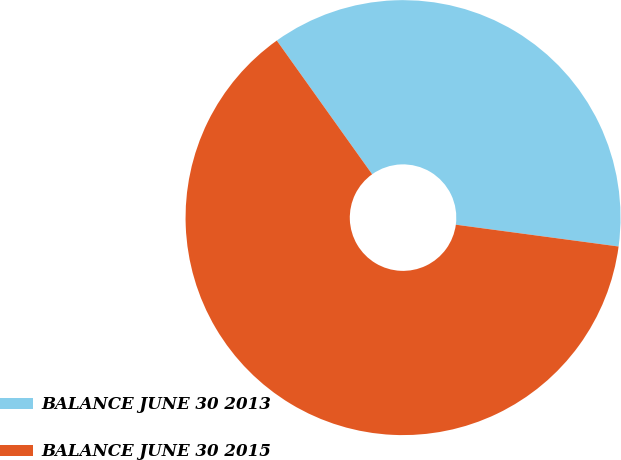<chart> <loc_0><loc_0><loc_500><loc_500><pie_chart><fcel>BALANCE JUNE 30 2013<fcel>BALANCE JUNE 30 2015<nl><fcel>36.98%<fcel>63.02%<nl></chart> 